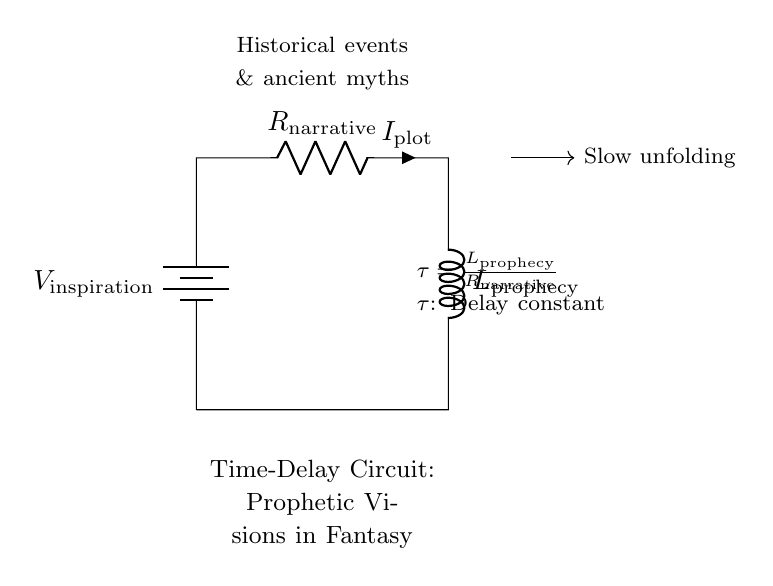What does the battery represent in this circuit? The battery symbolizes the source of inspiration, providing the necessary voltage to initiate the unfolding of prophetic visions in the narrative.
Answer: source of inspiration What is the role of the resistor in this circuit? The resistor, labeled as "narrative," determines the current flow within the circuit, impacting the time it takes for the prophetic visions to materialize.
Answer: limits current What does the inductor represent in this circuit? The inductor, labeled as "prophecy," symbolizes the accumulating knowledge or insights that take time to develop, reflecting the gradual unfolding of a storyline or vision.
Answer: accumulating knowledge What is the formula for the time-delay constant in this circuit? The time-delay constant is represented by the formula τ = Lprophecy / Rnarrative, demonstrating how the resistance and inductance affect the delay in the narrative's unfolding.
Answer: τ = Lprophecy / Rnarrative How does increasing resistance affect the time delay in this circuit? Increasing the resistance while keeping the inductance constant increases the time-delay constant τ, meaning the unfolding of the prophetic vision will be slower or take longer to manifest.
Answer: increases time delay What happens to the current if the inductor's value is increased? Increasing the inductor's value while maintaining the resistance constant allows for a larger time delay τ, which means the current will take longer to reach its peak, simulating a slower unfolding of the visionary aspect.
Answer: current peaks later What is the physical interpretation of the time-delay constant in narrative terms? The time-delay constant τ symbolizes the duration required for events or realizations to unfold within the context of a story, paralleling the gradual revelation of prophetic visions or insights in a fantasy narrative.
Answer: duration of realization 